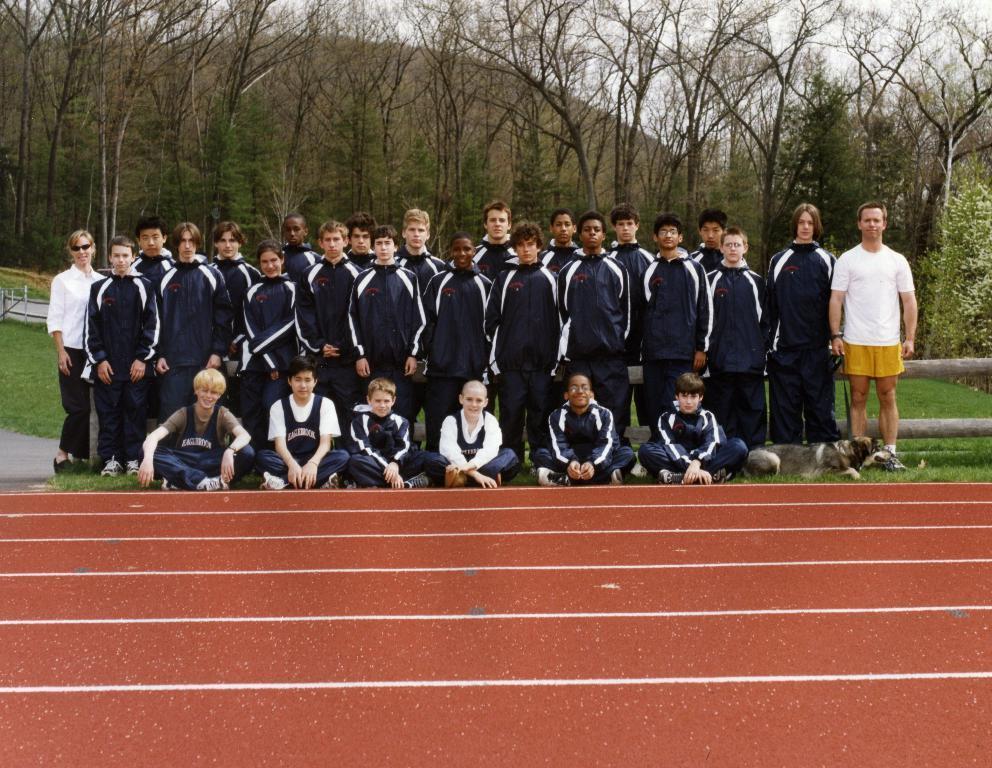Describe this image in one or two sentences. In this image, we can see people standing and some are sitting. In the background, there are trees. 